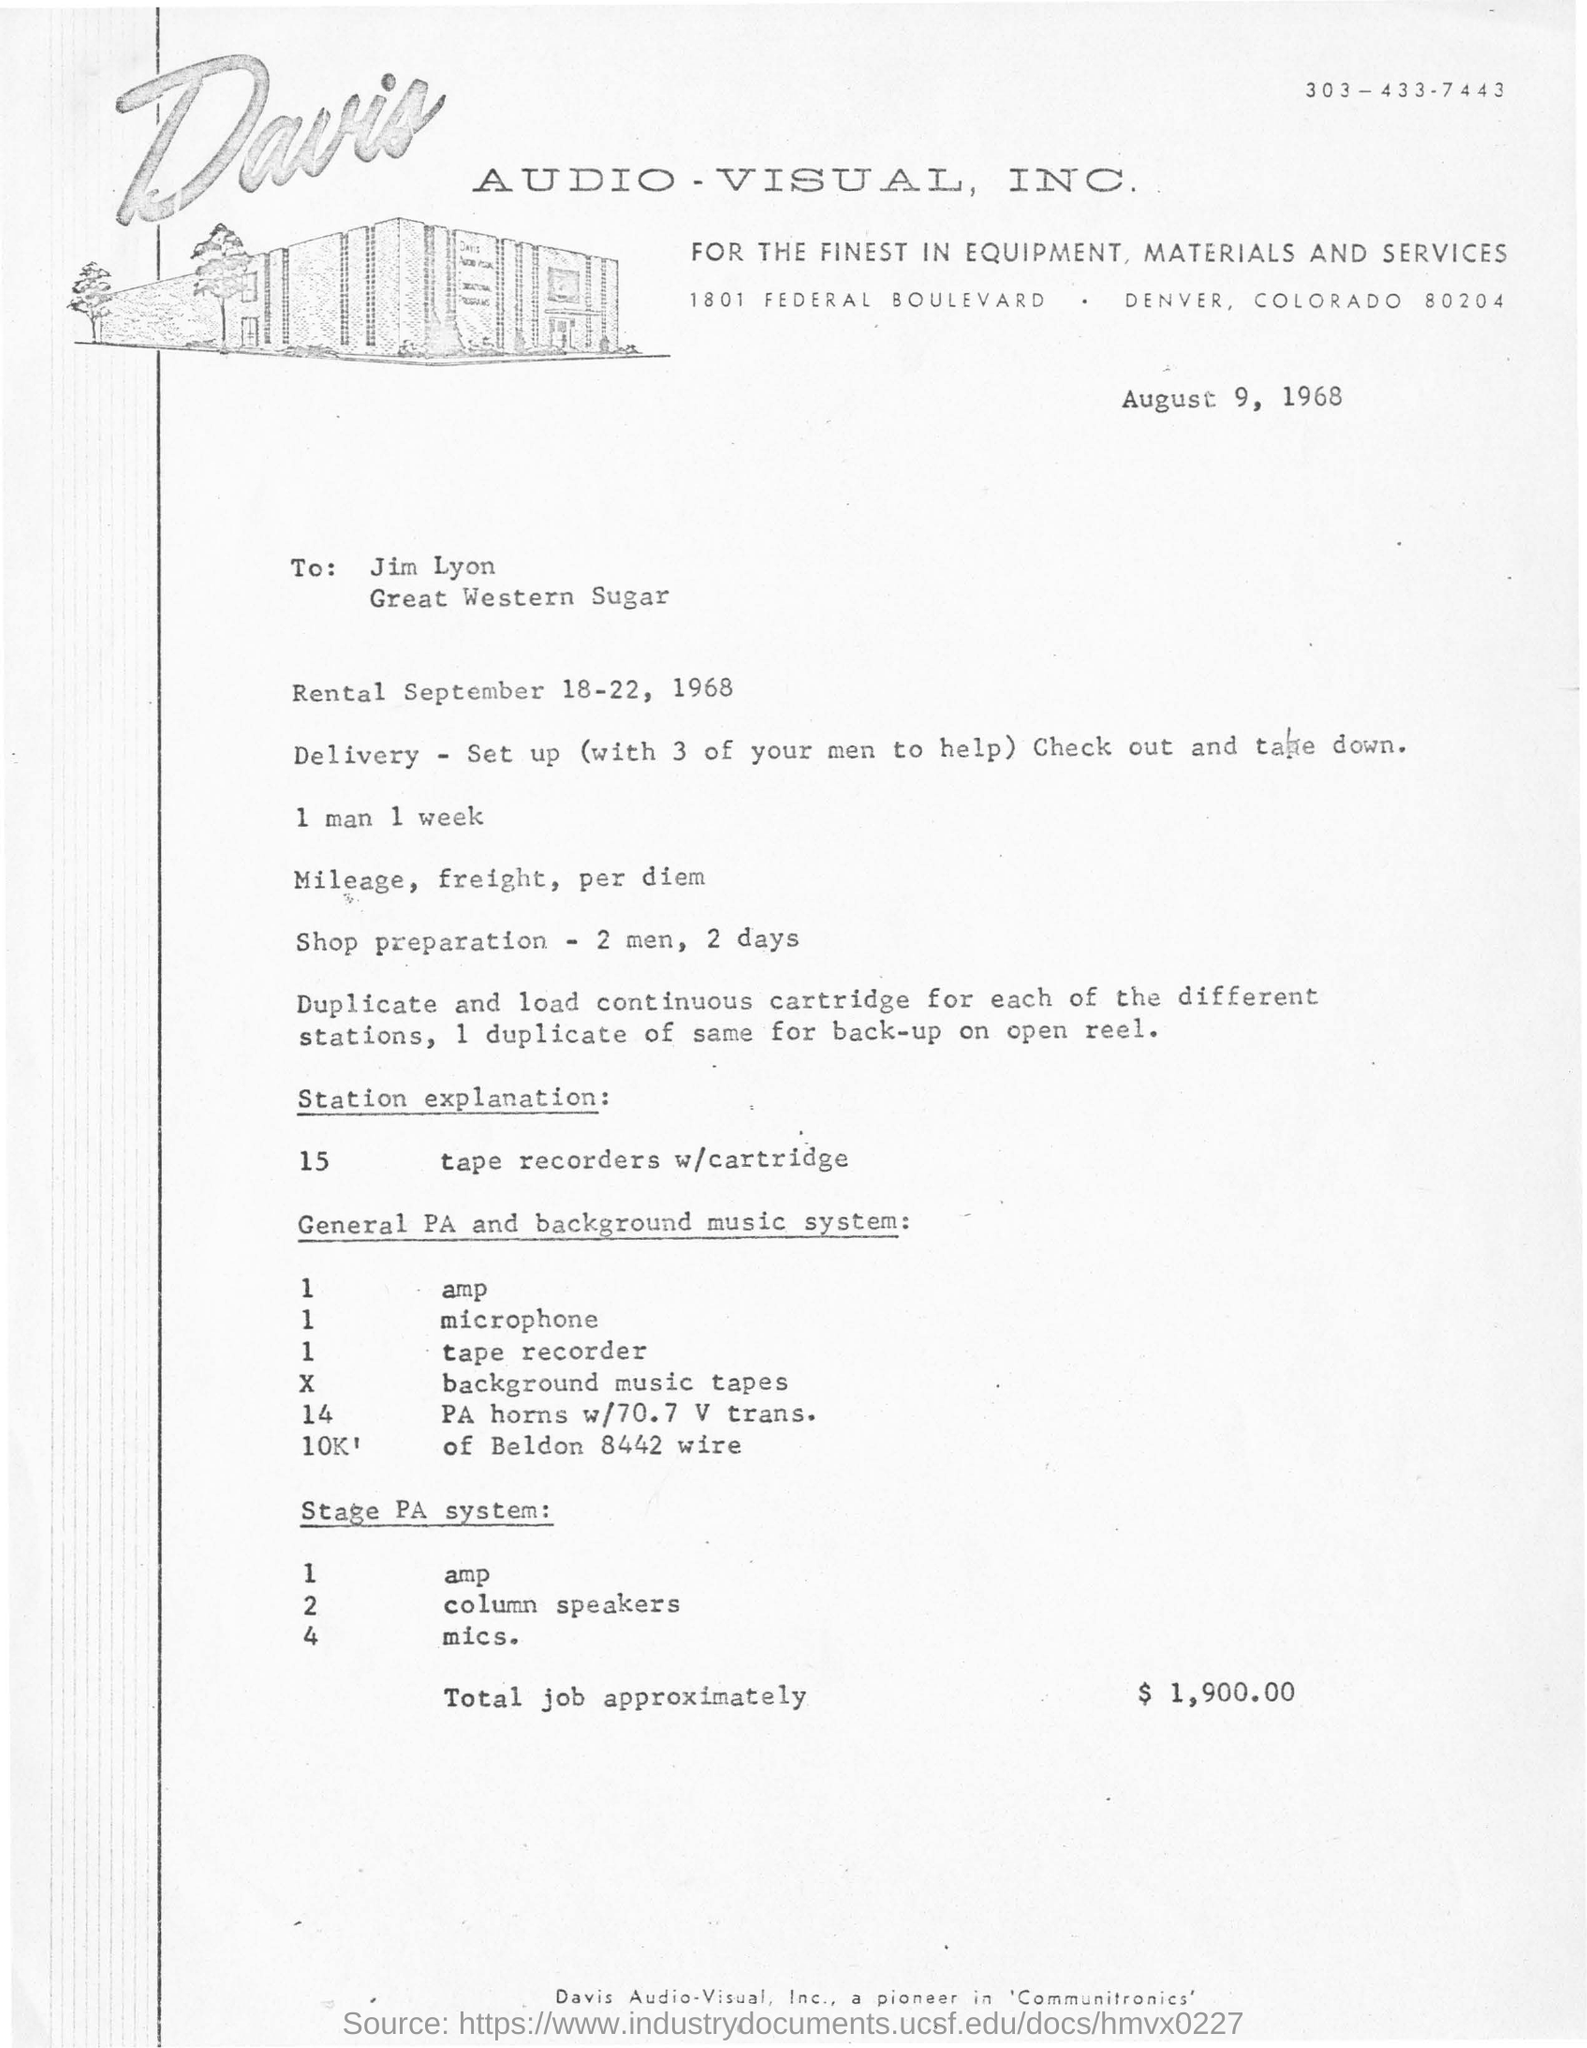Identify some key points in this picture. Total job is approximately valued at $1,900.00. The station explanation consists of 15 tape recorders with cartridges. To whom this letter was written is Jim Lyon. 